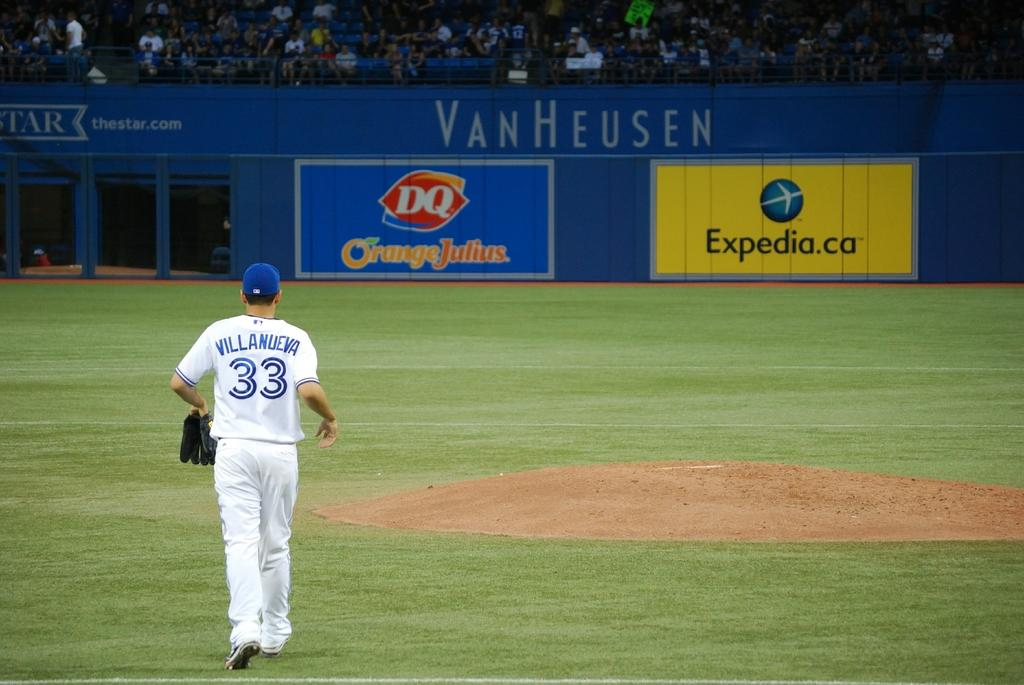<image>
Write a terse but informative summary of the picture. A baseball player named Villanueva on a baseball field 